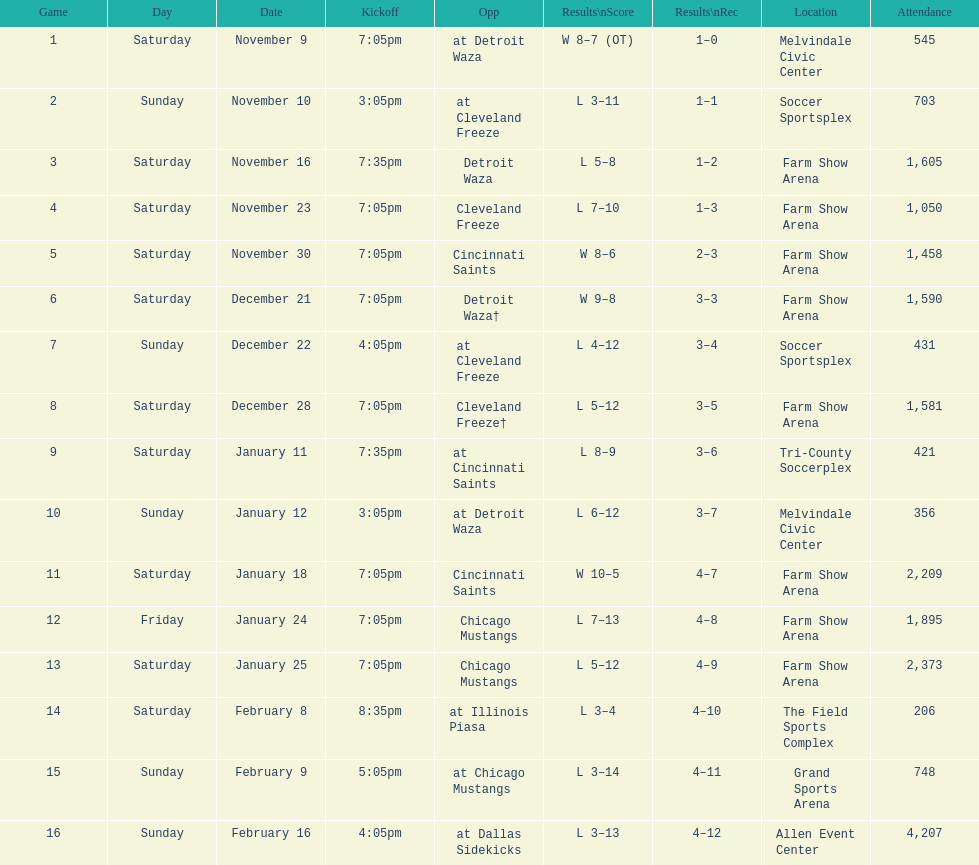Who was the first opponent on this list? Detroit Waza. 